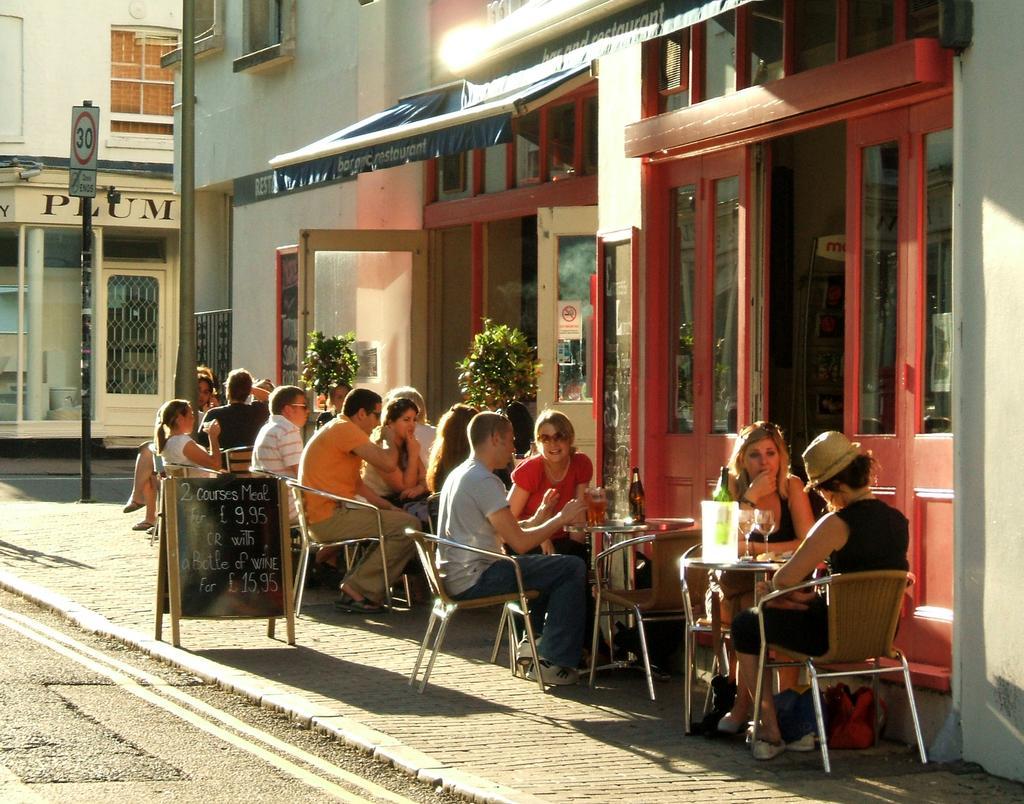Describe this image in one or two sentences. Here we can see a group of people sitting on chairs with tables in front of them outside a building and at the left side we can see speed limit board and there are buildings present 